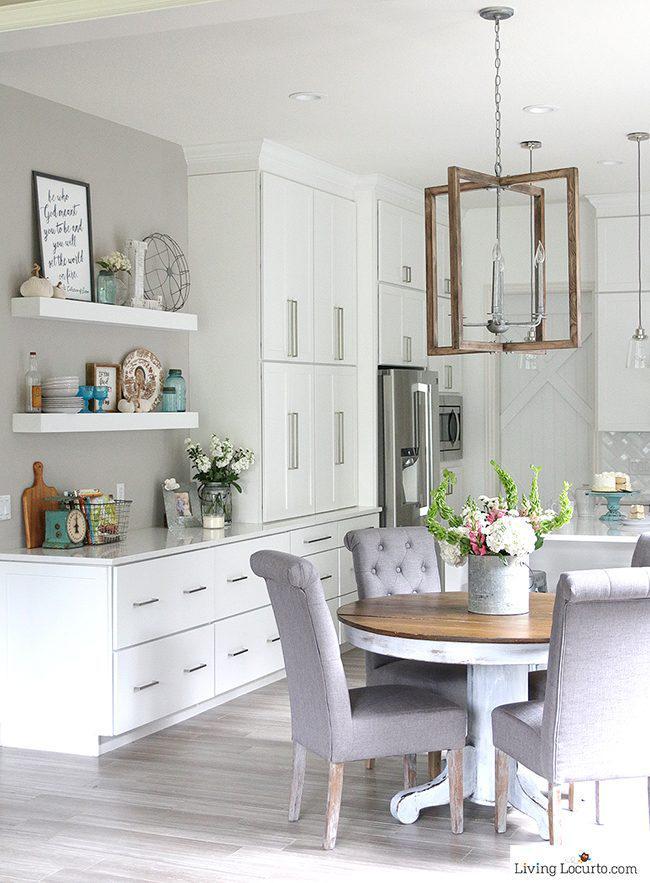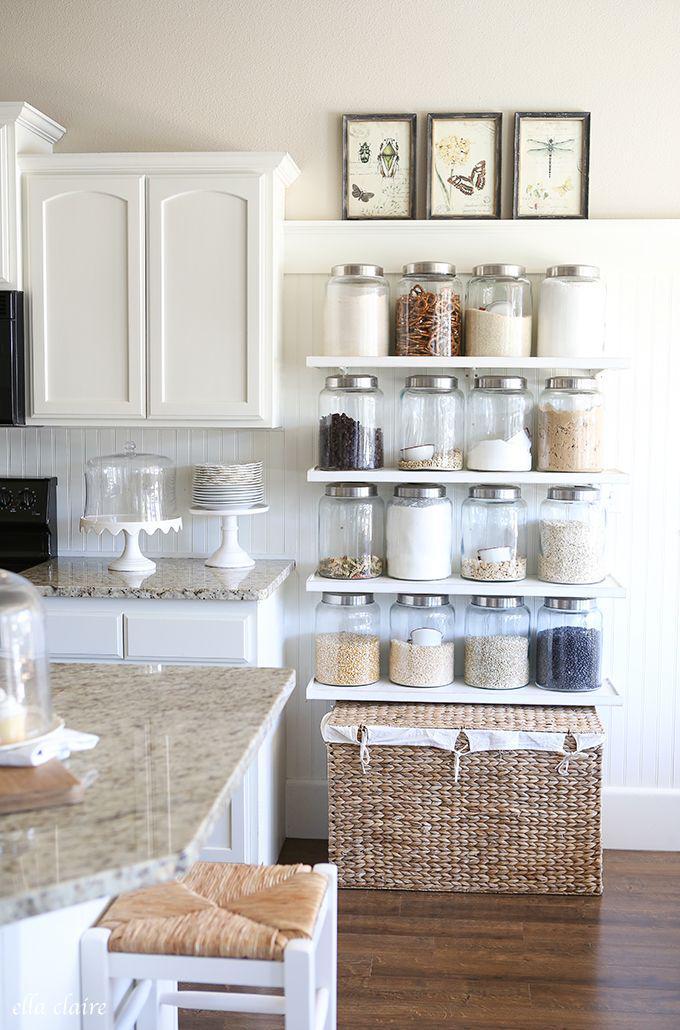The first image is the image on the left, the second image is the image on the right. Analyze the images presented: Is the assertion "There is a wooden floor visible in at least one of the images." valid? Answer yes or no. Yes. The first image is the image on the left, the second image is the image on the right. For the images displayed, is the sentence "At least one image shows floating brown shelves, and all images include at least one potted green plant." factually correct? Answer yes or no. No. 